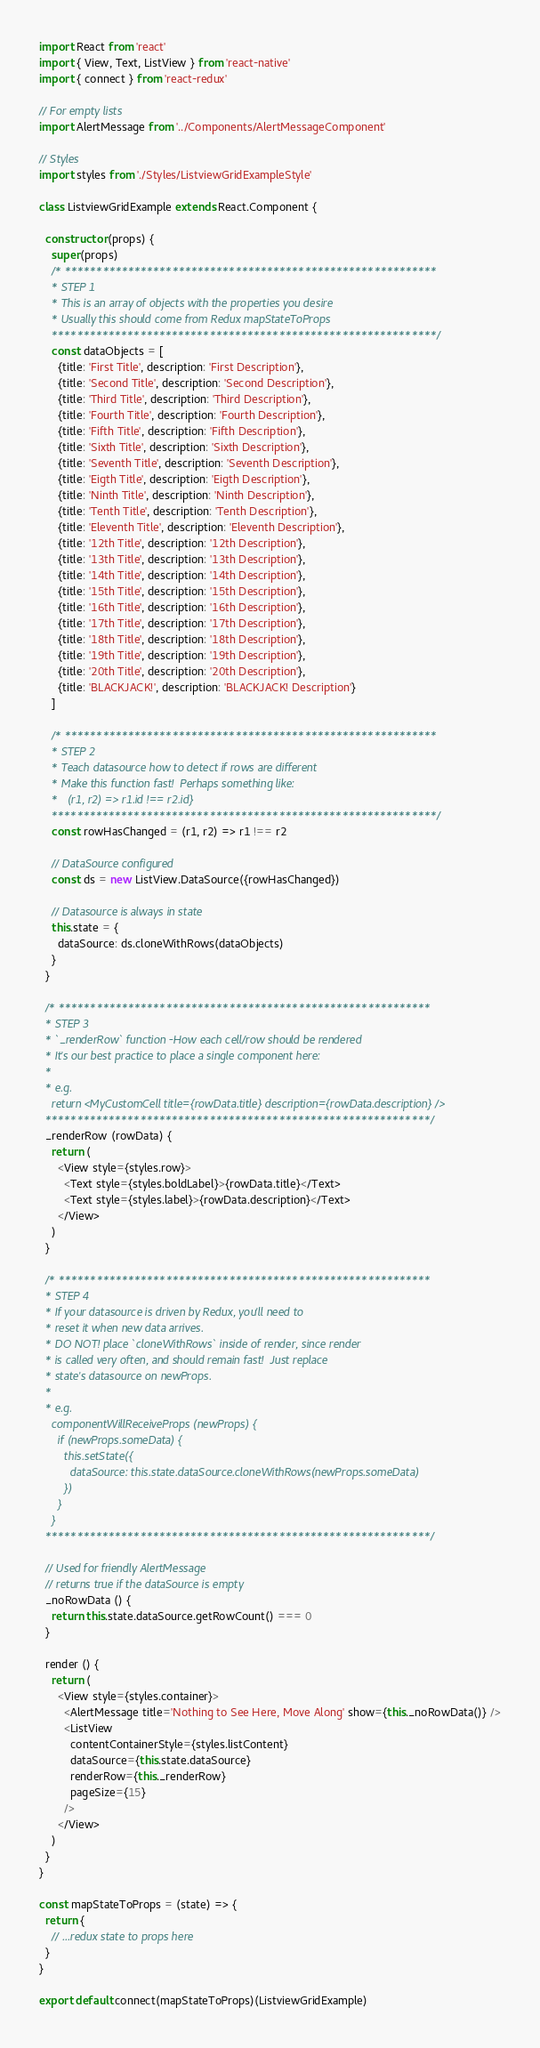Convert code to text. <code><loc_0><loc_0><loc_500><loc_500><_JavaScript_>import React from 'react'
import { View, Text, ListView } from 'react-native'
import { connect } from 'react-redux'

// For empty lists
import AlertMessage from '../Components/AlertMessageComponent'

// Styles
import styles from './Styles/ListviewGridExampleStyle'

class ListviewGridExample extends React.Component {

  constructor (props) {
    super(props)
    /* ***********************************************************
    * STEP 1
    * This is an array of objects with the properties you desire
    * Usually this should come from Redux mapStateToProps
    *************************************************************/
    const dataObjects = [
      {title: 'First Title', description: 'First Description'},
      {title: 'Second Title', description: 'Second Description'},
      {title: 'Third Title', description: 'Third Description'},
      {title: 'Fourth Title', description: 'Fourth Description'},
      {title: 'Fifth Title', description: 'Fifth Description'},
      {title: 'Sixth Title', description: 'Sixth Description'},
      {title: 'Seventh Title', description: 'Seventh Description'},
      {title: 'Eigth Title', description: 'Eigth Description'},
      {title: 'Ninth Title', description: 'Ninth Description'},
      {title: 'Tenth Title', description: 'Tenth Description'},
      {title: 'Eleventh Title', description: 'Eleventh Description'},
      {title: '12th Title', description: '12th Description'},
      {title: '13th Title', description: '13th Description'},
      {title: '14th Title', description: '14th Description'},
      {title: '15th Title', description: '15th Description'},
      {title: '16th Title', description: '16th Description'},
      {title: '17th Title', description: '17th Description'},
      {title: '18th Title', description: '18th Description'},
      {title: '19th Title', description: '19th Description'},
      {title: '20th Title', description: '20th Description'},
      {title: 'BLACKJACK!', description: 'BLACKJACK! Description'}
    ]

    /* ***********************************************************
    * STEP 2
    * Teach datasource how to detect if rows are different
    * Make this function fast!  Perhaps something like:
    *   (r1, r2) => r1.id !== r2.id}
    *************************************************************/
    const rowHasChanged = (r1, r2) => r1 !== r2

    // DataSource configured
    const ds = new ListView.DataSource({rowHasChanged})

    // Datasource is always in state
    this.state = {
      dataSource: ds.cloneWithRows(dataObjects)
    }
  }

  /* ***********************************************************
  * STEP 3
  * `_renderRow` function -How each cell/row should be rendered
  * It's our best practice to place a single component here:
  *
  * e.g.
    return <MyCustomCell title={rowData.title} description={rowData.description} />
  *************************************************************/
  _renderRow (rowData) {
    return (
      <View style={styles.row}>
        <Text style={styles.boldLabel}>{rowData.title}</Text>
        <Text style={styles.label}>{rowData.description}</Text>
      </View>
    )
  }

  /* ***********************************************************
  * STEP 4
  * If your datasource is driven by Redux, you'll need to
  * reset it when new data arrives.
  * DO NOT! place `cloneWithRows` inside of render, since render
  * is called very often, and should remain fast!  Just replace
  * state's datasource on newProps.
  *
  * e.g.
    componentWillReceiveProps (newProps) {
      if (newProps.someData) {
        this.setState({
          dataSource: this.state.dataSource.cloneWithRows(newProps.someData)
        })
      }
    }
  *************************************************************/

  // Used for friendly AlertMessage
  // returns true if the dataSource is empty
  _noRowData () {
    return this.state.dataSource.getRowCount() === 0
  }

  render () {
    return (
      <View style={styles.container}>
        <AlertMessage title='Nothing to See Here, Move Along' show={this._noRowData()} />
        <ListView
          contentContainerStyle={styles.listContent}
          dataSource={this.state.dataSource}
          renderRow={this._renderRow}
          pageSize={15}
        />
      </View>
    )
  }
}

const mapStateToProps = (state) => {
  return {
    // ...redux state to props here
  }
}

export default connect(mapStateToProps)(ListviewGridExample)
</code> 